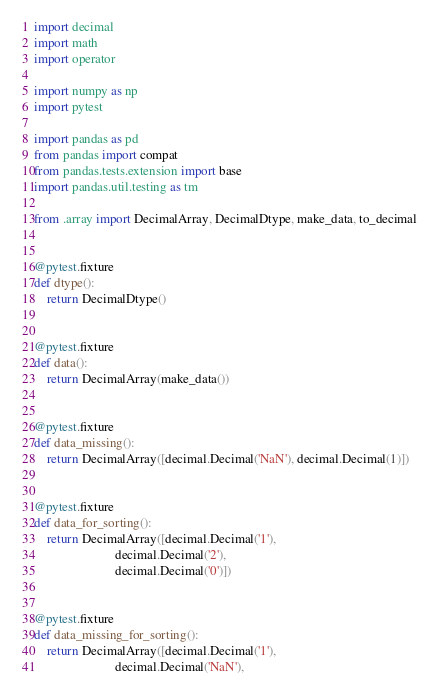<code> <loc_0><loc_0><loc_500><loc_500><_Python_>import decimal
import math
import operator

import numpy as np
import pytest

import pandas as pd
from pandas import compat
from pandas.tests.extension import base
import pandas.util.testing as tm

from .array import DecimalArray, DecimalDtype, make_data, to_decimal


@pytest.fixture
def dtype():
    return DecimalDtype()


@pytest.fixture
def data():
    return DecimalArray(make_data())


@pytest.fixture
def data_missing():
    return DecimalArray([decimal.Decimal('NaN'), decimal.Decimal(1)])


@pytest.fixture
def data_for_sorting():
    return DecimalArray([decimal.Decimal('1'),
                         decimal.Decimal('2'),
                         decimal.Decimal('0')])


@pytest.fixture
def data_missing_for_sorting():
    return DecimalArray([decimal.Decimal('1'),
                         decimal.Decimal('NaN'),</code> 